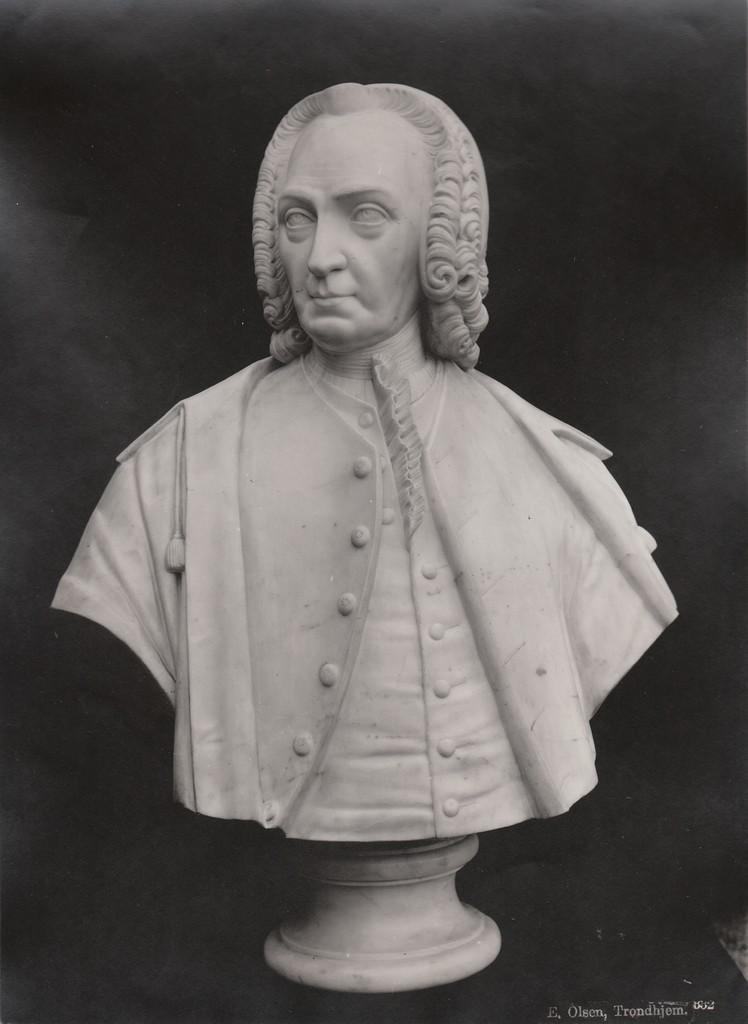What is the main subject of the image? There is a sculpture of a person in the image. What can be observed about the background of the image? The background of the image is dark. Is there any additional information or marking in the image? Yes, there is a watermark in the bottom right side of the image. What type of magic is being performed by the person in the image? There is no magic being performed in the image; it features a sculpture of a person. Can you see a lamp in the image? There is no lamp present in the image. 